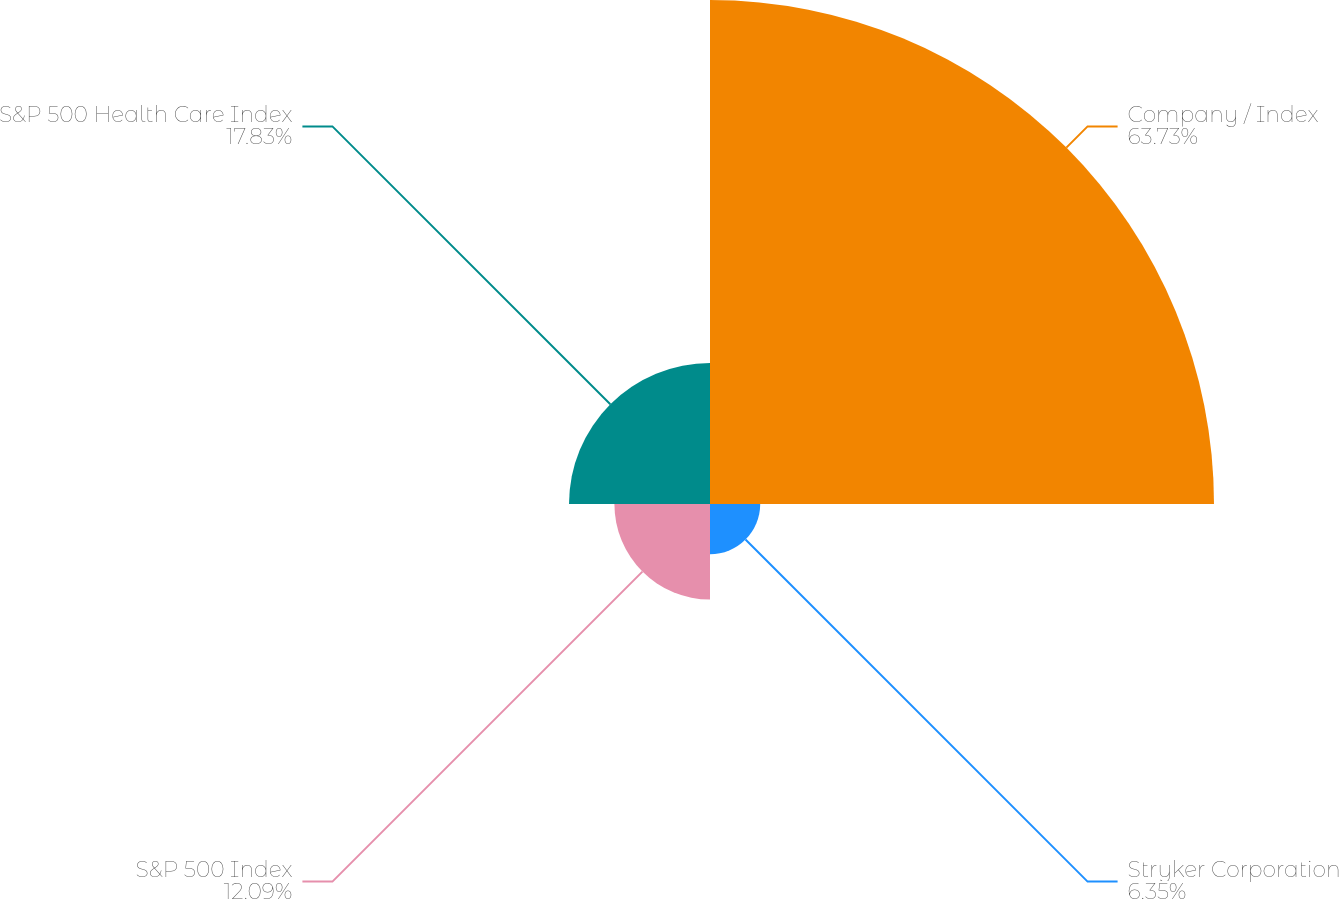Convert chart to OTSL. <chart><loc_0><loc_0><loc_500><loc_500><pie_chart><fcel>Company / Index<fcel>Stryker Corporation<fcel>S&P 500 Index<fcel>S&P 500 Health Care Index<nl><fcel>63.74%<fcel>6.35%<fcel>12.09%<fcel>17.83%<nl></chart> 